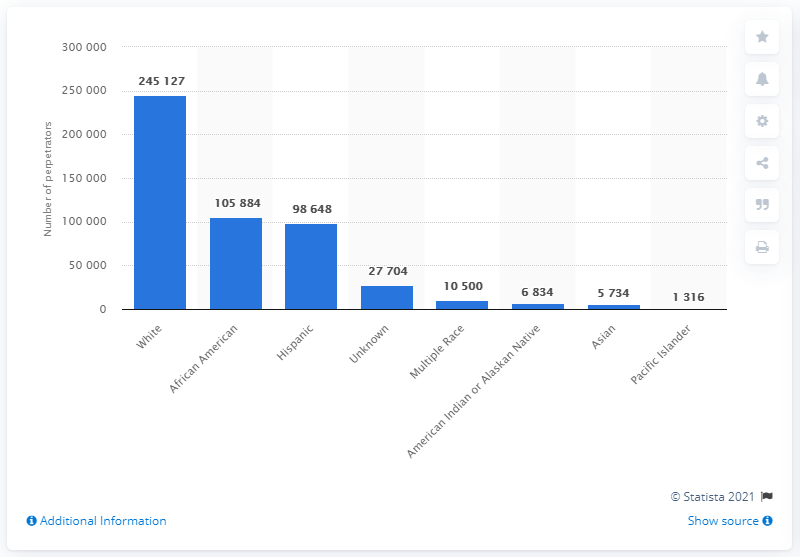List a handful of essential elements in this visual. The perpetrators of child abuse in the United States in 2019 were primarily of Asian ethnicity. 